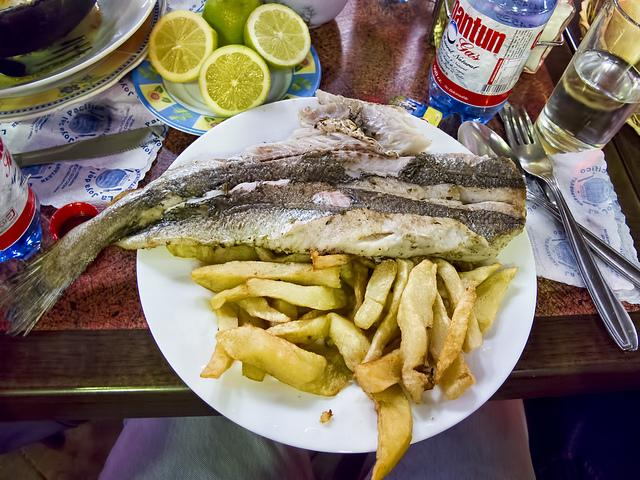What country's citizens are famous for eating this food combination? england 